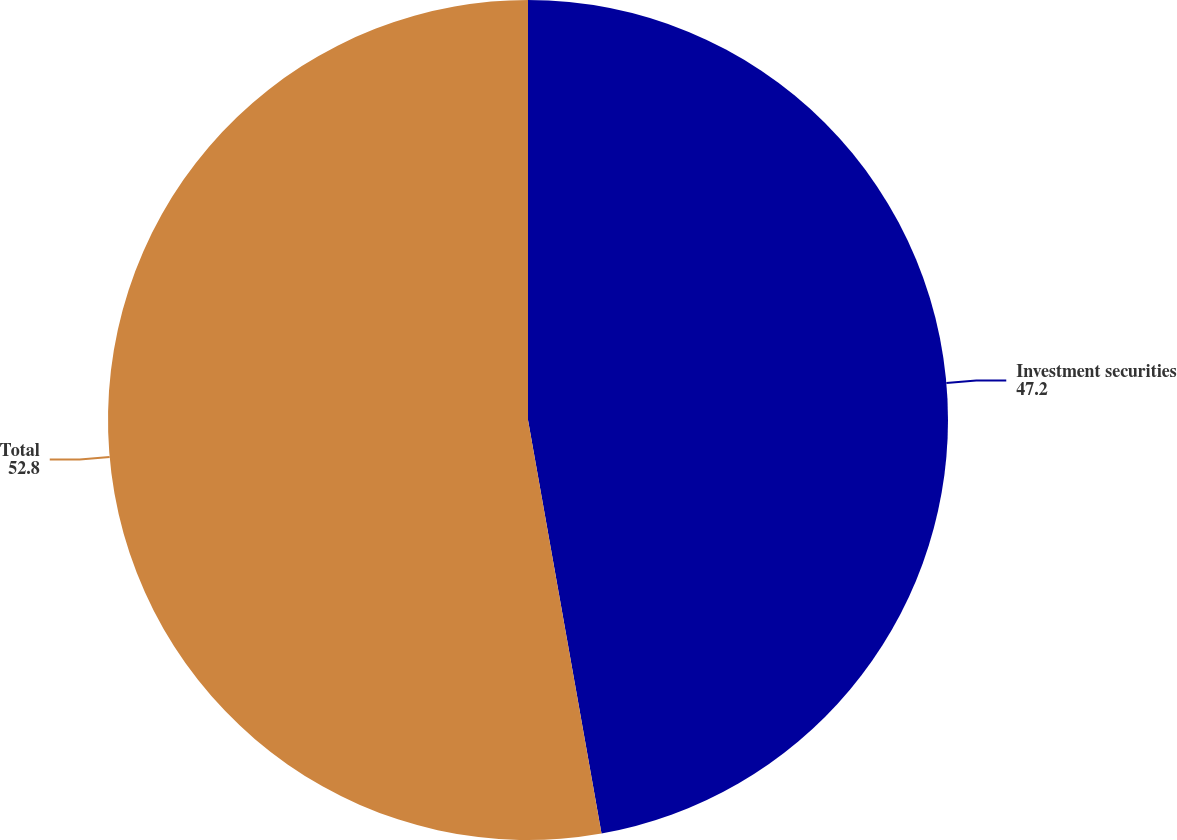<chart> <loc_0><loc_0><loc_500><loc_500><pie_chart><fcel>Investment securities<fcel>Total<nl><fcel>47.2%<fcel>52.8%<nl></chart> 